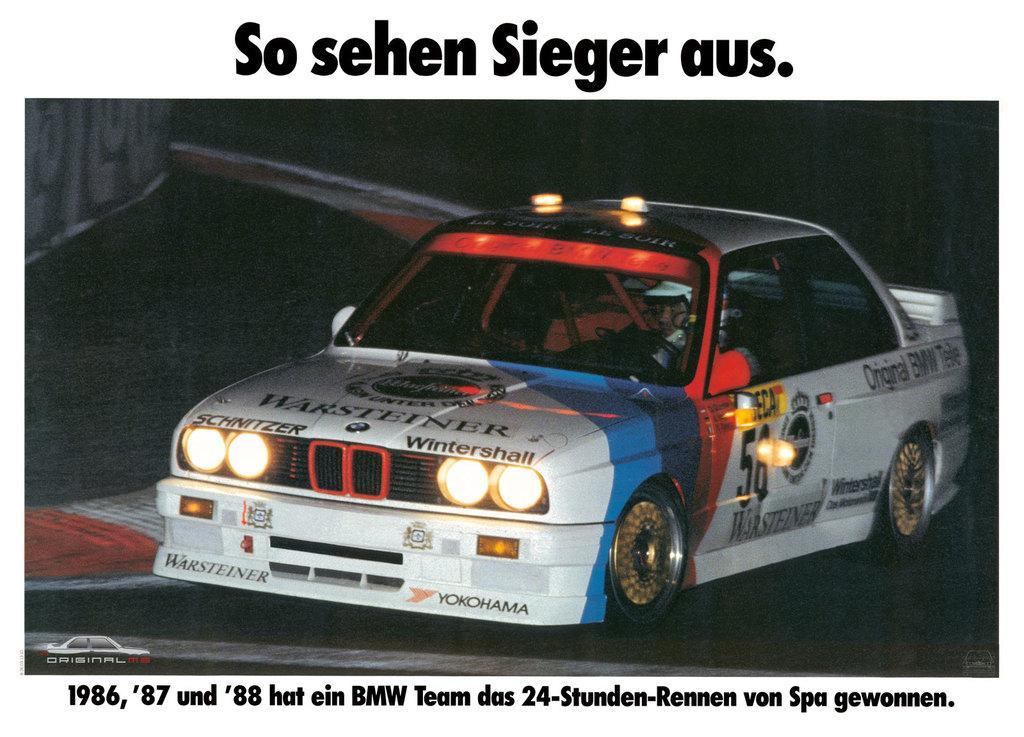Please provide a concise description of this image. In this image we can see the poster of a car and we can see the text written on the poster. 